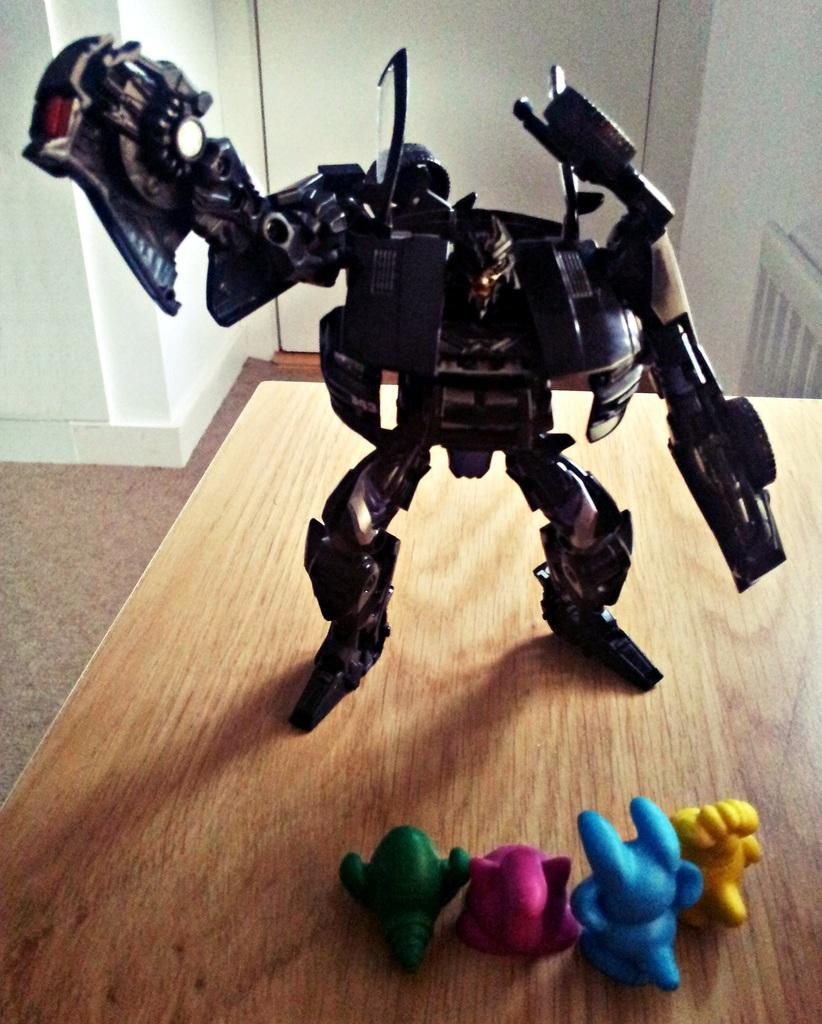What objects are on the table in the image? There are toys on the table in the image. How does the ring help with digestion in the image? There is no ring present in the image, and therefore no such activity related to digestion can be observed. 